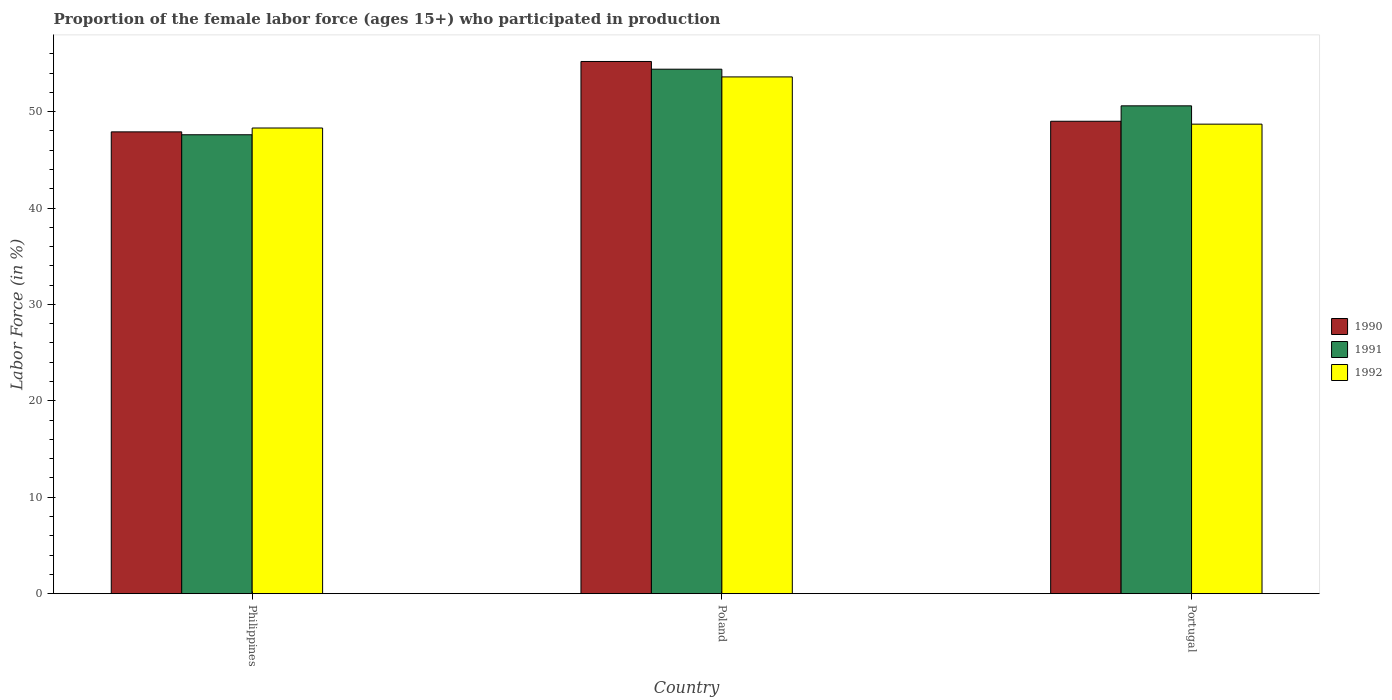How many different coloured bars are there?
Provide a succinct answer. 3. How many groups of bars are there?
Offer a terse response. 3. Are the number of bars per tick equal to the number of legend labels?
Provide a succinct answer. Yes. Are the number of bars on each tick of the X-axis equal?
Offer a terse response. Yes. How many bars are there on the 3rd tick from the left?
Provide a short and direct response. 3. What is the label of the 3rd group of bars from the left?
Provide a succinct answer. Portugal. What is the proportion of the female labor force who participated in production in 1990 in Poland?
Provide a succinct answer. 55.2. Across all countries, what is the maximum proportion of the female labor force who participated in production in 1991?
Your answer should be compact. 54.4. Across all countries, what is the minimum proportion of the female labor force who participated in production in 1992?
Give a very brief answer. 48.3. What is the total proportion of the female labor force who participated in production in 1991 in the graph?
Provide a short and direct response. 152.6. What is the difference between the proportion of the female labor force who participated in production in 1990 in Philippines and that in Poland?
Provide a succinct answer. -7.3. What is the difference between the proportion of the female labor force who participated in production in 1991 in Philippines and the proportion of the female labor force who participated in production in 1992 in Portugal?
Provide a succinct answer. -1.1. What is the average proportion of the female labor force who participated in production in 1990 per country?
Offer a very short reply. 50.7. What is the difference between the proportion of the female labor force who participated in production of/in 1992 and proportion of the female labor force who participated in production of/in 1990 in Portugal?
Offer a very short reply. -0.3. In how many countries, is the proportion of the female labor force who participated in production in 1992 greater than 46 %?
Your answer should be very brief. 3. What is the ratio of the proportion of the female labor force who participated in production in 1991 in Philippines to that in Poland?
Ensure brevity in your answer.  0.87. What is the difference between the highest and the second highest proportion of the female labor force who participated in production in 1992?
Ensure brevity in your answer.  0.4. What is the difference between the highest and the lowest proportion of the female labor force who participated in production in 1991?
Give a very brief answer. 6.8. Is the sum of the proportion of the female labor force who participated in production in 1991 in Philippines and Poland greater than the maximum proportion of the female labor force who participated in production in 1990 across all countries?
Ensure brevity in your answer.  Yes. What does the 3rd bar from the right in Philippines represents?
Your answer should be very brief. 1990. Is it the case that in every country, the sum of the proportion of the female labor force who participated in production in 1992 and proportion of the female labor force who participated in production in 1991 is greater than the proportion of the female labor force who participated in production in 1990?
Ensure brevity in your answer.  Yes. Are the values on the major ticks of Y-axis written in scientific E-notation?
Your answer should be very brief. No. Does the graph contain grids?
Your answer should be compact. No. Where does the legend appear in the graph?
Make the answer very short. Center right. How are the legend labels stacked?
Your response must be concise. Vertical. What is the title of the graph?
Make the answer very short. Proportion of the female labor force (ages 15+) who participated in production. What is the Labor Force (in %) in 1990 in Philippines?
Offer a terse response. 47.9. What is the Labor Force (in %) of 1991 in Philippines?
Make the answer very short. 47.6. What is the Labor Force (in %) of 1992 in Philippines?
Provide a short and direct response. 48.3. What is the Labor Force (in %) of 1990 in Poland?
Give a very brief answer. 55.2. What is the Labor Force (in %) in 1991 in Poland?
Provide a short and direct response. 54.4. What is the Labor Force (in %) in 1992 in Poland?
Offer a terse response. 53.6. What is the Labor Force (in %) of 1991 in Portugal?
Your response must be concise. 50.6. What is the Labor Force (in %) in 1992 in Portugal?
Your response must be concise. 48.7. Across all countries, what is the maximum Labor Force (in %) in 1990?
Your answer should be very brief. 55.2. Across all countries, what is the maximum Labor Force (in %) of 1991?
Provide a succinct answer. 54.4. Across all countries, what is the maximum Labor Force (in %) in 1992?
Provide a succinct answer. 53.6. Across all countries, what is the minimum Labor Force (in %) of 1990?
Offer a terse response. 47.9. Across all countries, what is the minimum Labor Force (in %) in 1991?
Give a very brief answer. 47.6. Across all countries, what is the minimum Labor Force (in %) of 1992?
Offer a terse response. 48.3. What is the total Labor Force (in %) of 1990 in the graph?
Provide a short and direct response. 152.1. What is the total Labor Force (in %) in 1991 in the graph?
Your answer should be very brief. 152.6. What is the total Labor Force (in %) of 1992 in the graph?
Your answer should be compact. 150.6. What is the difference between the Labor Force (in %) of 1992 in Philippines and that in Poland?
Make the answer very short. -5.3. What is the difference between the Labor Force (in %) in 1990 in Philippines and that in Portugal?
Offer a very short reply. -1.1. What is the difference between the Labor Force (in %) of 1991 in Philippines and that in Portugal?
Offer a very short reply. -3. What is the difference between the Labor Force (in %) in 1990 in Poland and that in Portugal?
Your answer should be very brief. 6.2. What is the difference between the Labor Force (in %) in 1991 in Poland and that in Portugal?
Ensure brevity in your answer.  3.8. What is the difference between the Labor Force (in %) in 1992 in Poland and that in Portugal?
Ensure brevity in your answer.  4.9. What is the difference between the Labor Force (in %) in 1991 in Philippines and the Labor Force (in %) in 1992 in Poland?
Offer a very short reply. -6. What is the difference between the Labor Force (in %) in 1990 in Philippines and the Labor Force (in %) in 1991 in Portugal?
Your answer should be compact. -2.7. What is the difference between the Labor Force (in %) in 1990 in Philippines and the Labor Force (in %) in 1992 in Portugal?
Provide a short and direct response. -0.8. What is the difference between the Labor Force (in %) in 1991 in Poland and the Labor Force (in %) in 1992 in Portugal?
Ensure brevity in your answer.  5.7. What is the average Labor Force (in %) in 1990 per country?
Your answer should be compact. 50.7. What is the average Labor Force (in %) of 1991 per country?
Your answer should be very brief. 50.87. What is the average Labor Force (in %) in 1992 per country?
Ensure brevity in your answer.  50.2. What is the difference between the Labor Force (in %) of 1990 and Labor Force (in %) of 1991 in Philippines?
Provide a short and direct response. 0.3. What is the difference between the Labor Force (in %) of 1990 and Labor Force (in %) of 1992 in Philippines?
Offer a very short reply. -0.4. What is the difference between the Labor Force (in %) of 1991 and Labor Force (in %) of 1992 in Philippines?
Keep it short and to the point. -0.7. What is the difference between the Labor Force (in %) in 1991 and Labor Force (in %) in 1992 in Poland?
Your answer should be compact. 0.8. What is the difference between the Labor Force (in %) of 1991 and Labor Force (in %) of 1992 in Portugal?
Keep it short and to the point. 1.9. What is the ratio of the Labor Force (in %) in 1990 in Philippines to that in Poland?
Give a very brief answer. 0.87. What is the ratio of the Labor Force (in %) in 1991 in Philippines to that in Poland?
Provide a short and direct response. 0.88. What is the ratio of the Labor Force (in %) of 1992 in Philippines to that in Poland?
Your answer should be compact. 0.9. What is the ratio of the Labor Force (in %) in 1990 in Philippines to that in Portugal?
Your response must be concise. 0.98. What is the ratio of the Labor Force (in %) of 1991 in Philippines to that in Portugal?
Keep it short and to the point. 0.94. What is the ratio of the Labor Force (in %) in 1992 in Philippines to that in Portugal?
Your answer should be very brief. 0.99. What is the ratio of the Labor Force (in %) of 1990 in Poland to that in Portugal?
Give a very brief answer. 1.13. What is the ratio of the Labor Force (in %) in 1991 in Poland to that in Portugal?
Offer a terse response. 1.08. What is the ratio of the Labor Force (in %) of 1992 in Poland to that in Portugal?
Offer a terse response. 1.1. What is the difference between the highest and the second highest Labor Force (in %) in 1990?
Offer a terse response. 6.2. 